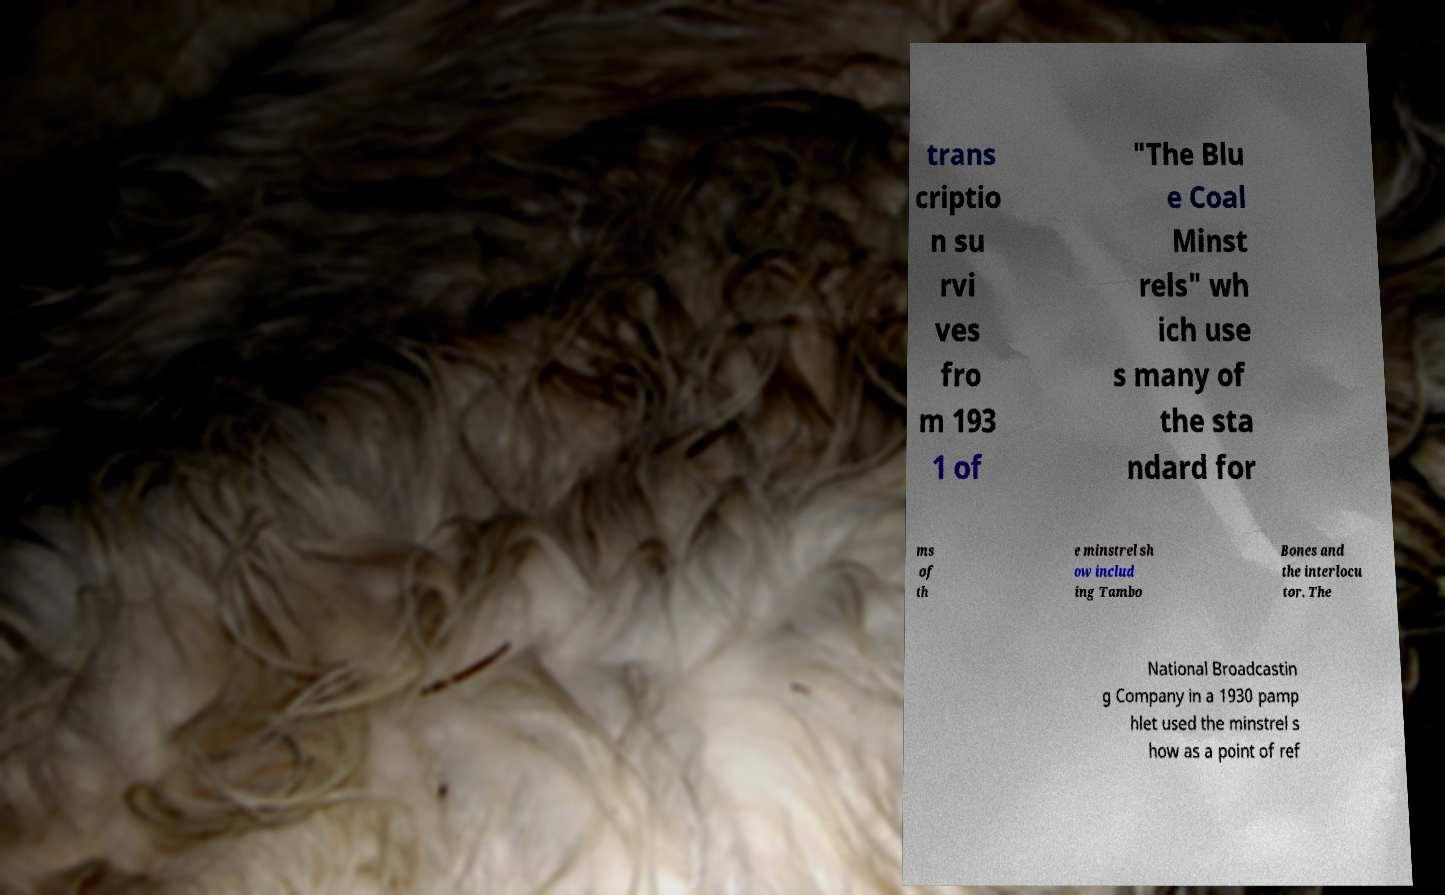Can you read and provide the text displayed in the image?This photo seems to have some interesting text. Can you extract and type it out for me? trans criptio n su rvi ves fro m 193 1 of "The Blu e Coal Minst rels" wh ich use s many of the sta ndard for ms of th e minstrel sh ow includ ing Tambo Bones and the interlocu tor. The National Broadcastin g Company in a 1930 pamp hlet used the minstrel s how as a point of ref 